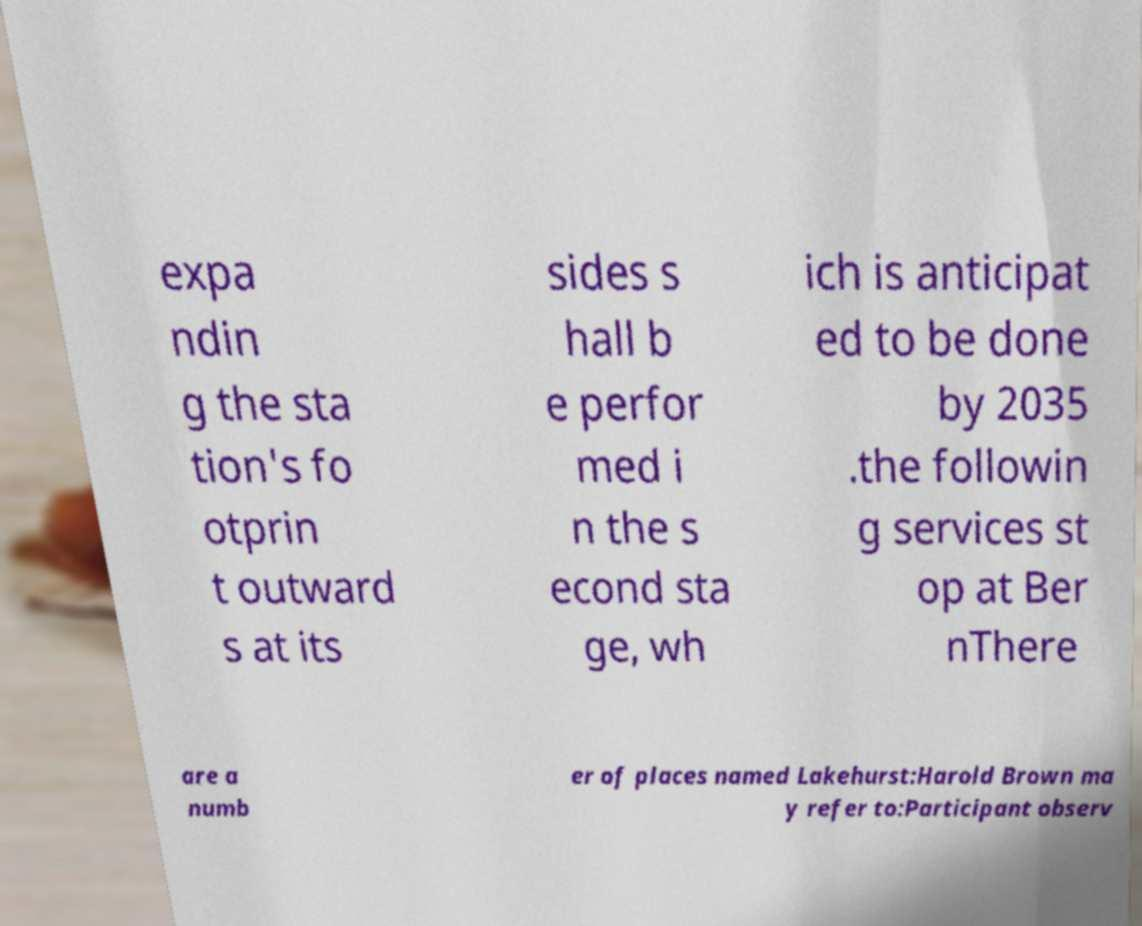Could you extract and type out the text from this image? expa ndin g the sta tion's fo otprin t outward s at its sides s hall b e perfor med i n the s econd sta ge, wh ich is anticipat ed to be done by 2035 .the followin g services st op at Ber nThere are a numb er of places named Lakehurst:Harold Brown ma y refer to:Participant observ 